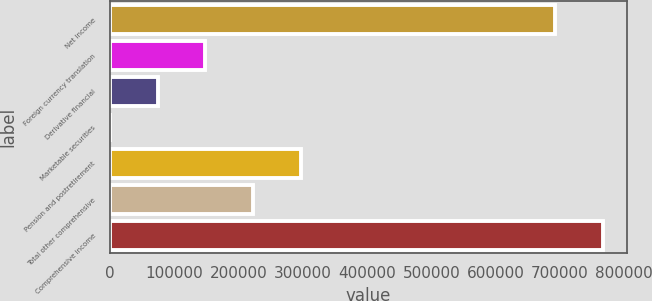Convert chart. <chart><loc_0><loc_0><loc_500><loc_500><bar_chart><fcel>Net income<fcel>Foreign currency translation<fcel>Derivative financial<fcel>Marketable securities<fcel>Pension and postretirement<fcel>Total other comprehensive<fcel>Comprehensive income<nl><fcel>692164<fcel>148478<fcel>74288.8<fcel>100<fcel>296855<fcel>222666<fcel>766353<nl></chart> 